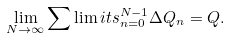Convert formula to latex. <formula><loc_0><loc_0><loc_500><loc_500>\lim _ { N \rightarrow \infty } \sum \lim i t s _ { n = 0 } ^ { N - 1 } \Delta Q _ { n } = Q .</formula> 